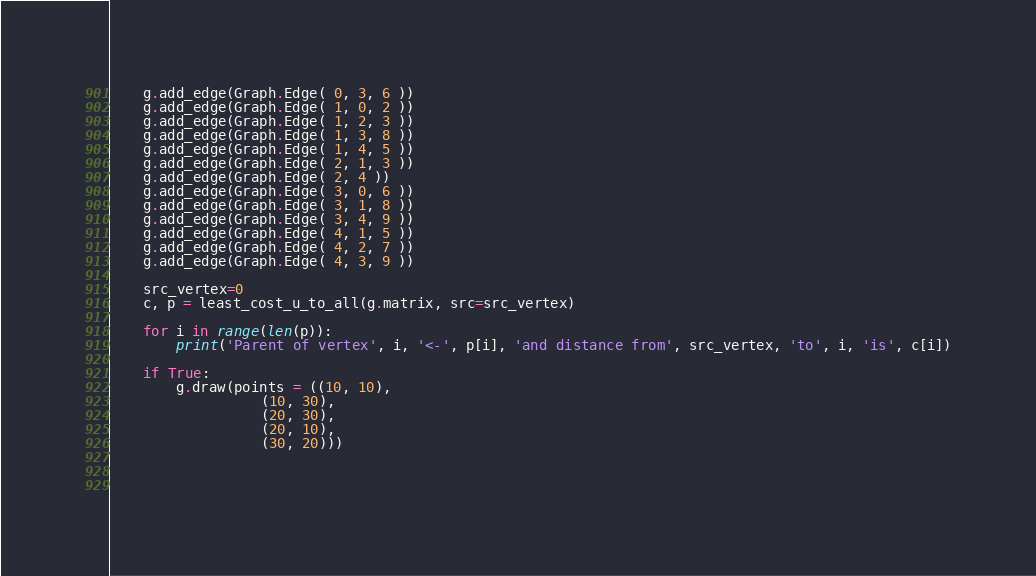<code> <loc_0><loc_0><loc_500><loc_500><_Python_>    g.add_edge(Graph.Edge( 0, 3, 6 ))
    g.add_edge(Graph.Edge( 1, 0, 2 ))
    g.add_edge(Graph.Edge( 1, 2, 3 ))
    g.add_edge(Graph.Edge( 1, 3, 8 ))
    g.add_edge(Graph.Edge( 1, 4, 5 ))
    g.add_edge(Graph.Edge( 2, 1, 3 ))
    g.add_edge(Graph.Edge( 2, 4 ))
    g.add_edge(Graph.Edge( 3, 0, 6 ))
    g.add_edge(Graph.Edge( 3, 1, 8 ))
    g.add_edge(Graph.Edge( 3, 4, 9 ))
    g.add_edge(Graph.Edge( 4, 1, 5 ))
    g.add_edge(Graph.Edge( 4, 2, 7 ))
    g.add_edge(Graph.Edge( 4, 3, 9 ))

    src_vertex=0
    c, p = least_cost_u_to_all(g.matrix, src=src_vertex)
    
    for i in range(len(p)):
        print('Parent of vertex', i, '<-', p[i], 'and distance from', src_vertex, 'to', i, 'is', c[i])

    if True:    
        g.draw(points = ((10, 10),
                  (10, 30),
                  (20, 30),
                  (20, 10),
                  (30, 20)))


        
</code> 